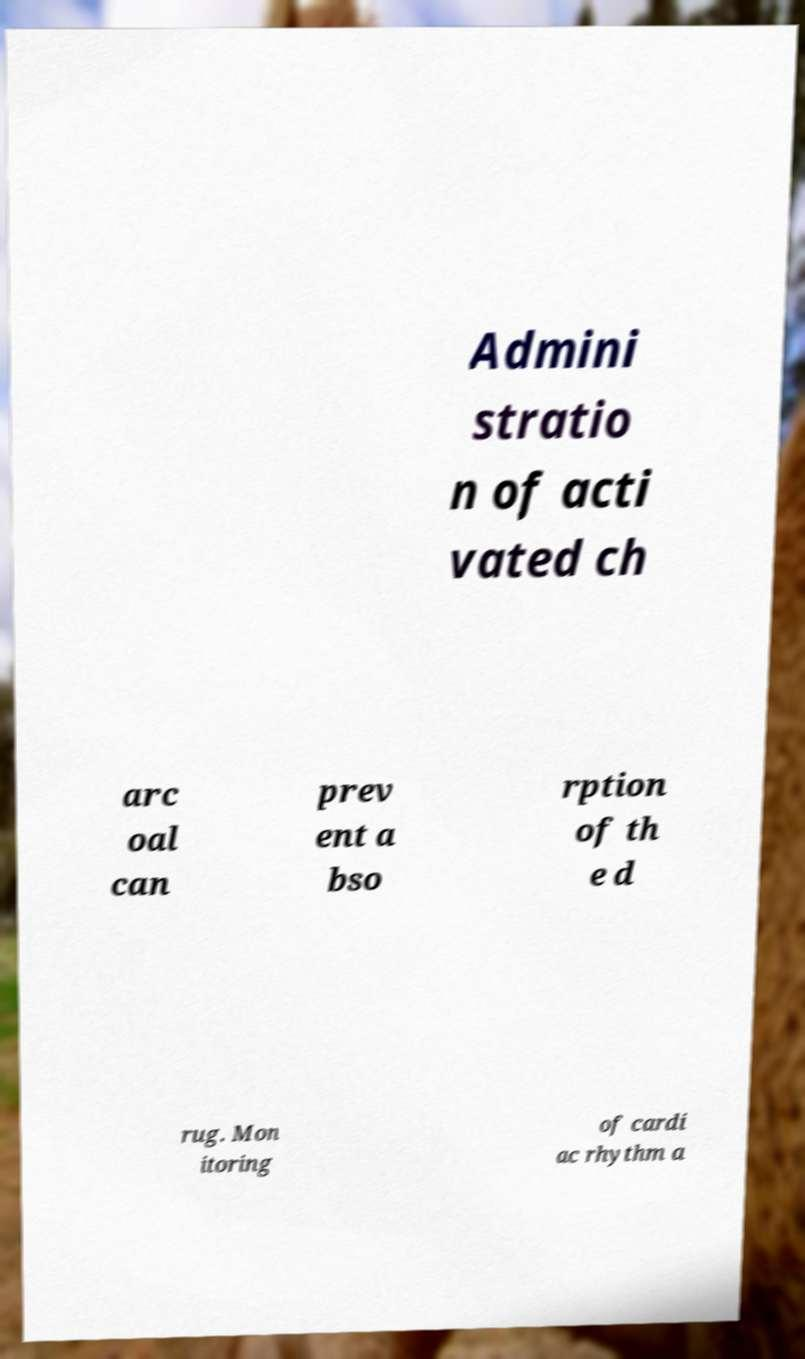For documentation purposes, I need the text within this image transcribed. Could you provide that? Admini stratio n of acti vated ch arc oal can prev ent a bso rption of th e d rug. Mon itoring of cardi ac rhythm a 